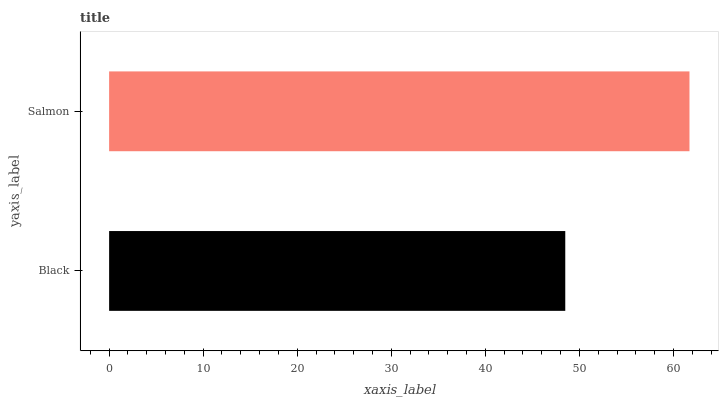Is Black the minimum?
Answer yes or no. Yes. Is Salmon the maximum?
Answer yes or no. Yes. Is Salmon the minimum?
Answer yes or no. No. Is Salmon greater than Black?
Answer yes or no. Yes. Is Black less than Salmon?
Answer yes or no. Yes. Is Black greater than Salmon?
Answer yes or no. No. Is Salmon less than Black?
Answer yes or no. No. Is Salmon the high median?
Answer yes or no. Yes. Is Black the low median?
Answer yes or no. Yes. Is Black the high median?
Answer yes or no. No. Is Salmon the low median?
Answer yes or no. No. 